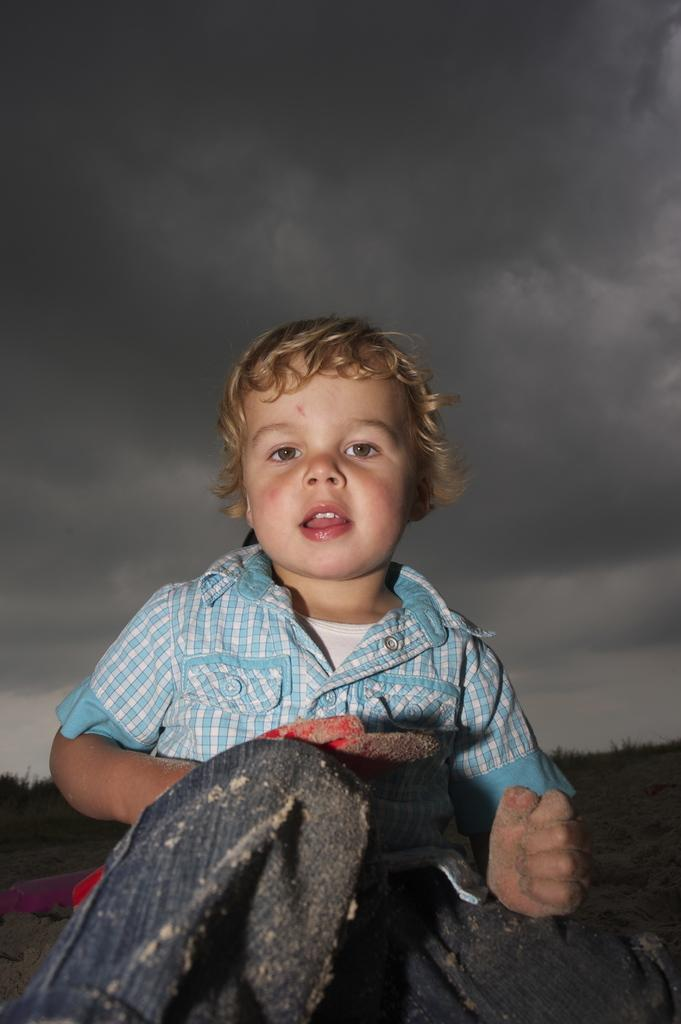What is the boy in the image doing? The boy is sitting in the image. What is the boy holding in the image? The boy is holding an object. What can be seen on the ground in the image? There is an object on the ground in the image. What type of vegetation is present in the image? There are plants in the image. What is visible in the background of the image? The sky is visible in the background of the image. What fact can be learned about the boy's mouth from the image? There is no information about the boy's mouth in the image, so no fact can be learned about it. 